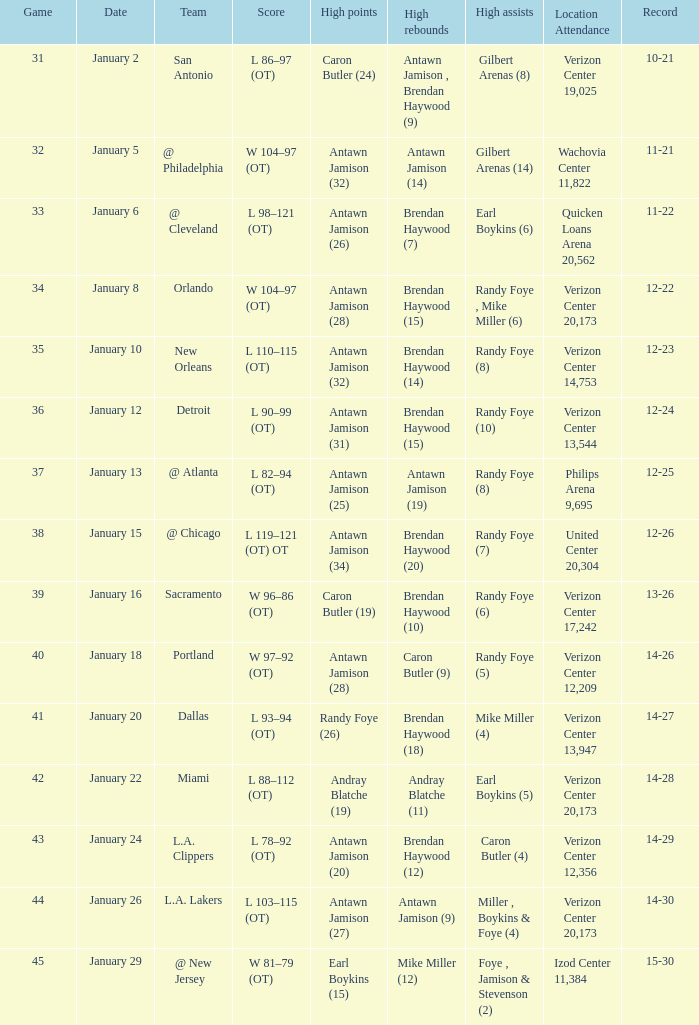Can you give me this table as a dict? {'header': ['Game', 'Date', 'Team', 'Score', 'High points', 'High rebounds', 'High assists', 'Location Attendance', 'Record'], 'rows': [['31', 'January 2', 'San Antonio', 'L 86–97 (OT)', 'Caron Butler (24)', 'Antawn Jamison , Brendan Haywood (9)', 'Gilbert Arenas (8)', 'Verizon Center 19,025', '10-21'], ['32', 'January 5', '@ Philadelphia', 'W 104–97 (OT)', 'Antawn Jamison (32)', 'Antawn Jamison (14)', 'Gilbert Arenas (14)', 'Wachovia Center 11,822', '11-21'], ['33', 'January 6', '@ Cleveland', 'L 98–121 (OT)', 'Antawn Jamison (26)', 'Brendan Haywood (7)', 'Earl Boykins (6)', 'Quicken Loans Arena 20,562', '11-22'], ['34', 'January 8', 'Orlando', 'W 104–97 (OT)', 'Antawn Jamison (28)', 'Brendan Haywood (15)', 'Randy Foye , Mike Miller (6)', 'Verizon Center 20,173', '12-22'], ['35', 'January 10', 'New Orleans', 'L 110–115 (OT)', 'Antawn Jamison (32)', 'Brendan Haywood (14)', 'Randy Foye (8)', 'Verizon Center 14,753', '12-23'], ['36', 'January 12', 'Detroit', 'L 90–99 (OT)', 'Antawn Jamison (31)', 'Brendan Haywood (15)', 'Randy Foye (10)', 'Verizon Center 13,544', '12-24'], ['37', 'January 13', '@ Atlanta', 'L 82–94 (OT)', 'Antawn Jamison (25)', 'Antawn Jamison (19)', 'Randy Foye (8)', 'Philips Arena 9,695', '12-25'], ['38', 'January 15', '@ Chicago', 'L 119–121 (OT) OT', 'Antawn Jamison (34)', 'Brendan Haywood (20)', 'Randy Foye (7)', 'United Center 20,304', '12-26'], ['39', 'January 16', 'Sacramento', 'W 96–86 (OT)', 'Caron Butler (19)', 'Brendan Haywood (10)', 'Randy Foye (6)', 'Verizon Center 17,242', '13-26'], ['40', 'January 18', 'Portland', 'W 97–92 (OT)', 'Antawn Jamison (28)', 'Caron Butler (9)', 'Randy Foye (5)', 'Verizon Center 12,209', '14-26'], ['41', 'January 20', 'Dallas', 'L 93–94 (OT)', 'Randy Foye (26)', 'Brendan Haywood (18)', 'Mike Miller (4)', 'Verizon Center 13,947', '14-27'], ['42', 'January 22', 'Miami', 'L 88–112 (OT)', 'Andray Blatche (19)', 'Andray Blatche (11)', 'Earl Boykins (5)', 'Verizon Center 20,173', '14-28'], ['43', 'January 24', 'L.A. Clippers', 'L 78–92 (OT)', 'Antawn Jamison (20)', 'Brendan Haywood (12)', 'Caron Butler (4)', 'Verizon Center 12,356', '14-29'], ['44', 'January 26', 'L.A. Lakers', 'L 103–115 (OT)', 'Antawn Jamison (27)', 'Antawn Jamison (9)', 'Miller , Boykins & Foye (4)', 'Verizon Center 20,173', '14-30'], ['45', 'January 29', '@ New Jersey', 'W 81–79 (OT)', 'Earl Boykins (15)', 'Mike Miller (12)', 'Foye , Jamison & Stevenson (2)', 'Izod Center 11,384', '15-30']]} Who scored the most points on january 2? Caron Butler (24). 